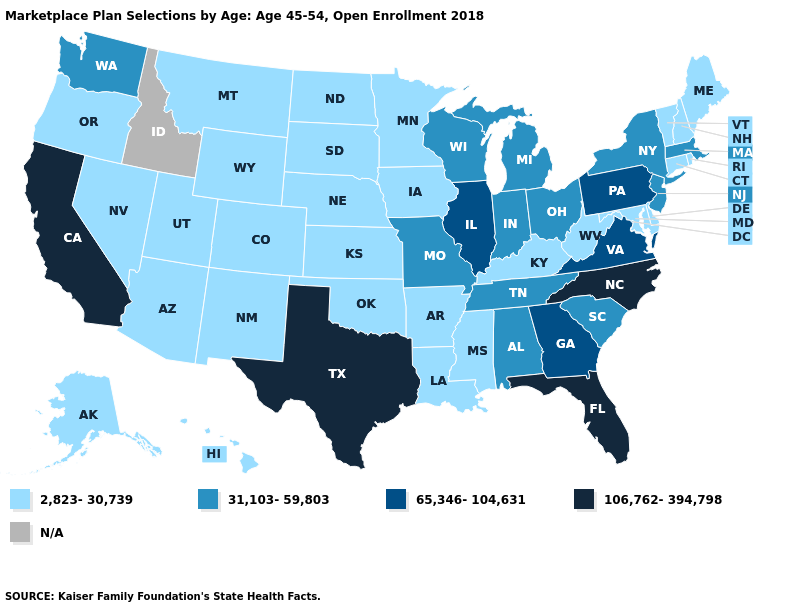What is the lowest value in the USA?
Write a very short answer. 2,823-30,739. Which states have the highest value in the USA?
Quick response, please. California, Florida, North Carolina, Texas. Which states have the lowest value in the MidWest?
Answer briefly. Iowa, Kansas, Minnesota, Nebraska, North Dakota, South Dakota. Which states have the lowest value in the USA?
Be succinct. Alaska, Arizona, Arkansas, Colorado, Connecticut, Delaware, Hawaii, Iowa, Kansas, Kentucky, Louisiana, Maine, Maryland, Minnesota, Mississippi, Montana, Nebraska, Nevada, New Hampshire, New Mexico, North Dakota, Oklahoma, Oregon, Rhode Island, South Dakota, Utah, Vermont, West Virginia, Wyoming. What is the highest value in the West ?
Be succinct. 106,762-394,798. What is the lowest value in the South?
Answer briefly. 2,823-30,739. Among the states that border South Carolina , which have the highest value?
Short answer required. North Carolina. Name the states that have a value in the range N/A?
Keep it brief. Idaho. Is the legend a continuous bar?
Quick response, please. No. Does the map have missing data?
Concise answer only. Yes. Does the map have missing data?
Keep it brief. Yes. How many symbols are there in the legend?
Quick response, please. 5. Does the first symbol in the legend represent the smallest category?
Quick response, please. Yes. Which states hav the highest value in the South?
Quick response, please. Florida, North Carolina, Texas. What is the value of Nevada?
Give a very brief answer. 2,823-30,739. 